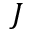<formula> <loc_0><loc_0><loc_500><loc_500>J</formula> 